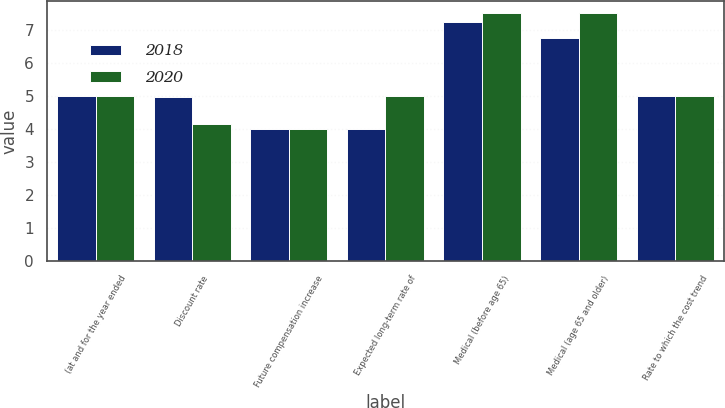Convert chart. <chart><loc_0><loc_0><loc_500><loc_500><stacked_bar_chart><ecel><fcel>(at and for the year ended<fcel>Discount rate<fcel>Future compensation increase<fcel>Expected long-term rate of<fcel>Medical (before age 65)<fcel>Medical (age 65 and older)<fcel>Rate to which the cost trend<nl><fcel>2018<fcel>5<fcel>4.96<fcel>4<fcel>4<fcel>7.25<fcel>6.75<fcel>5<nl><fcel>2020<fcel>5<fcel>4.15<fcel>4<fcel>5<fcel>7.5<fcel>7.5<fcel>5<nl></chart> 